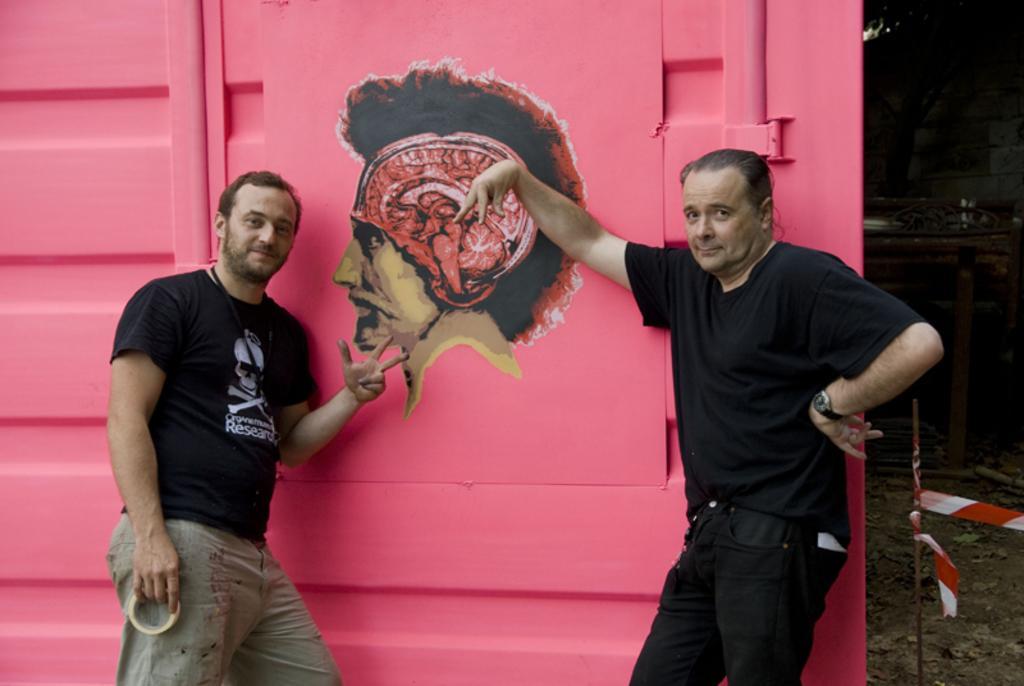Describe this image in one or two sentences. In the image there are two men standing in front of a pink background, they are posing for the photo and there is an image of a man on the pink background. 